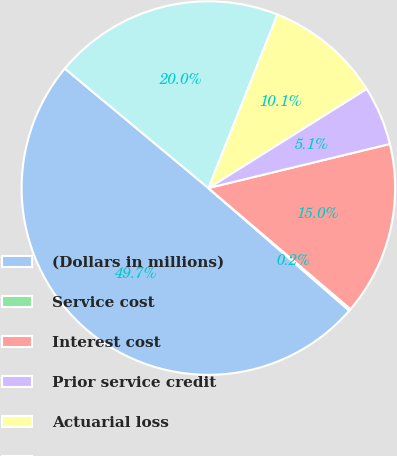Convert chart to OTSL. <chart><loc_0><loc_0><loc_500><loc_500><pie_chart><fcel>(Dollars in millions)<fcel>Service cost<fcel>Interest cost<fcel>Prior service credit<fcel>Actuarial loss<fcel>Net periodic benefit cost<nl><fcel>49.65%<fcel>0.17%<fcel>15.02%<fcel>5.12%<fcel>10.07%<fcel>19.97%<nl></chart> 